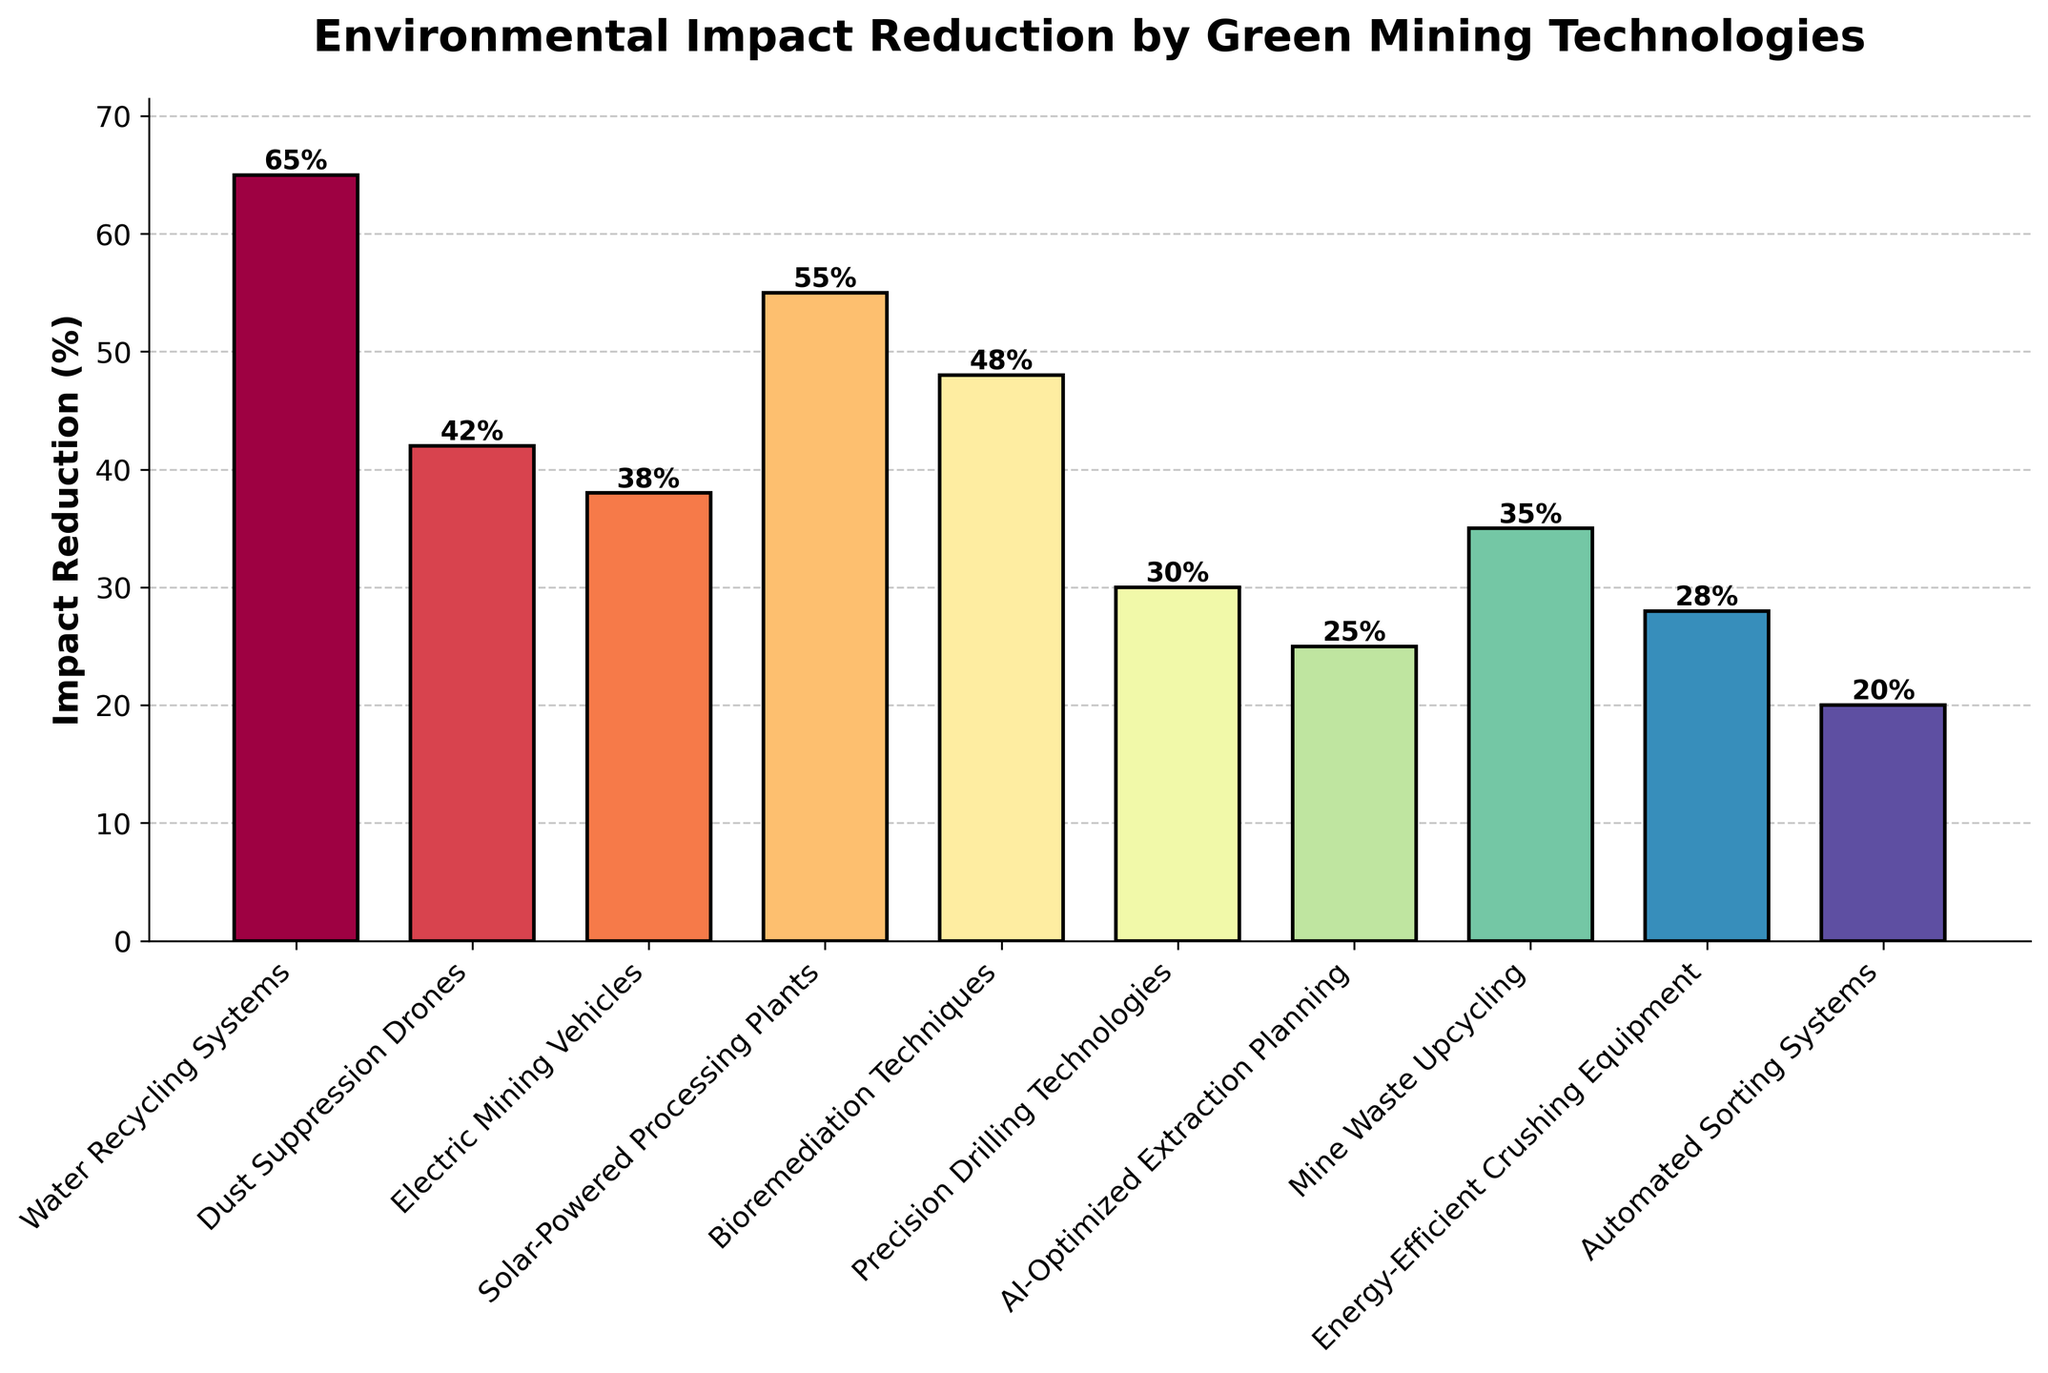Which green mining technology achieves the highest environmental impact reduction? The highest bar represents the environmental impact reduction achieved by Water Recycling Systems, with a reduction of 65%.
Answer: Water Recycling Systems Which technology achieves a higher impact reduction, Dust Suppression Drones or Electric Mining Vehicles? Dust Suppression Drones has a higher impact reduction with 42%, compared to Electric Mining Vehicles' 38%.
Answer: Dust Suppression Drones By how much does the impact reduction of Solar-Powered Processing Plants exceed that of Mine Waste Upcycling? Solar-Powered Processing Plants have an impact reduction of 55%, while Mine Waste Upcycling has 35%. The difference is 55% - 35% = 20%.
Answer: 20% What is the sum of the impact reduction percentages of the three technologies with the lowest reductions? The three technologies with the lowest reductions are Automated Sorting Systems (20%), AI-Optimized Extraction Planning (25%), and Precision Drilling Technologies (30%). The sum is 20% + 25% + 30% = 75%.
Answer: 75% How much higher is the impact reduction of Bioremediation Techniques compared to that of Energy-Efficient Crushing Equipment? Bioremediation Techniques has an impact reduction of 48%, and Energy-Efficient Crushing Equipment has 28%. The difference is 48% - 28% = 20%.
Answer: 20% Which technology achieves an impact reduction closest to 50%? By looking at the impact reductions, Bioremediation Techniques achieves a reduction of 48%, which is closest to 50%.
Answer: Bioremediation Techniques What is the average impact reduction percentage of the technologies achieving more than 40% reduction? The technologies achieving more than 40% reduction are Water Recycling Systems (65%), Dust Suppression Drones (42%), and Solar-Powered Processing Plants (55%). The average is (65% + 42% + 55%) / 3 = 54%.
Answer: 54% Rank the technologies from highest to lowest in terms of impact reduction achieved. The impact reductions in descending order are Water Recycling Systems (65%), Solar-Powered Processing Plants (55%), Bioremediation Techniques (48%), Dust Suppression Drones (42%), Electric Mining Vehicles (38%), Mine Waste Upcycling (35%), Precision Drilling Technologies (30%), Energy-Efficient Crushing Equipment (28%), AI-Optimized Extraction Planning (25%), Automated Sorting Systems (20%).
Answer: Water Recycling Systems, Solar-Powered Processing Plants, Bioremediation Techniques, Dust Suppression Drones, Electric Mining Vehicles, Mine Waste Upcycling, Precision Drilling Technologies, Energy-Efficient Crushing Equipment, AI-Optimized Extraction Planning, Automated Sorting Systems 